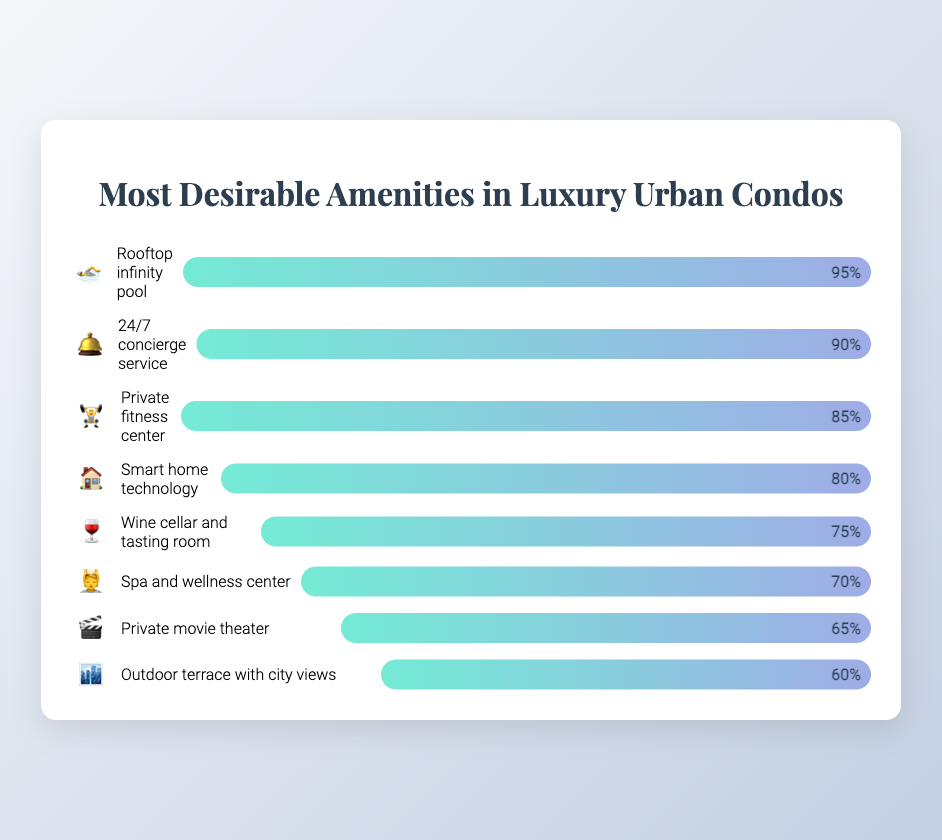Which amenity has the highest desirability? Look at the figure and identify the bar with the widest fill, indicating the highest percentage value. The "Rooftop infinity pool" has a desirability of 95%, which is the highest.
Answer: Rooftop infinity pool How desirable is the "Private fitness center" amenity? The bar for "Private fitness center" shows a 85% desirability as indicated by the label on the bar fill.
Answer: 85% Which amenity is least desirable? The shortest bar in the figure, which represents the lowest desirability, corresponds to the "Outdoor terrace with city views" at 60%.
Answer: Outdoor terrace with city views What is the average desirability of all amenities? Sum all the desirability values (95 + 90 + 85 + 80 + 75 + 70 + 65 + 60) and divide by the number of amenities (8). The calculation is (620 / 8) = 77.5.
Answer: 77.5% Which amenities have a desirability of 80% or higher? Identify all bars with a fill of 80% or more. These are: "Rooftop infinity pool" (95%), "24/7 concierge service" (90%), "Private fitness center" (85%), and "Smart home technology" (80%).
Answer: Rooftop infinity pool, 24/7 concierge service, Private fitness center, Smart home technology How much more desirable is the "24/7 concierge service" compared to the "Spa and wellness center"? Calculate the difference in desirability between the two amenities: 90% - 70% = 20%.
Answer: 20% What percentage of amenities have a desirability of 70% or higher? Count the amenities with desirability values of 70% or more (7 amenities out of 8), then find the percentage: (7 / 8) * 100 = 87.5%.
Answer: 87.5% Is the desirability of the "Wine cellar and tasting room" higher than the "Private movie theater"? Compare the desirability values: "Wine cellar and tasting room" has 75% and "Private movie theater" has 65%. Since 75% > 65%, the answer is yes.
Answer: Yes 